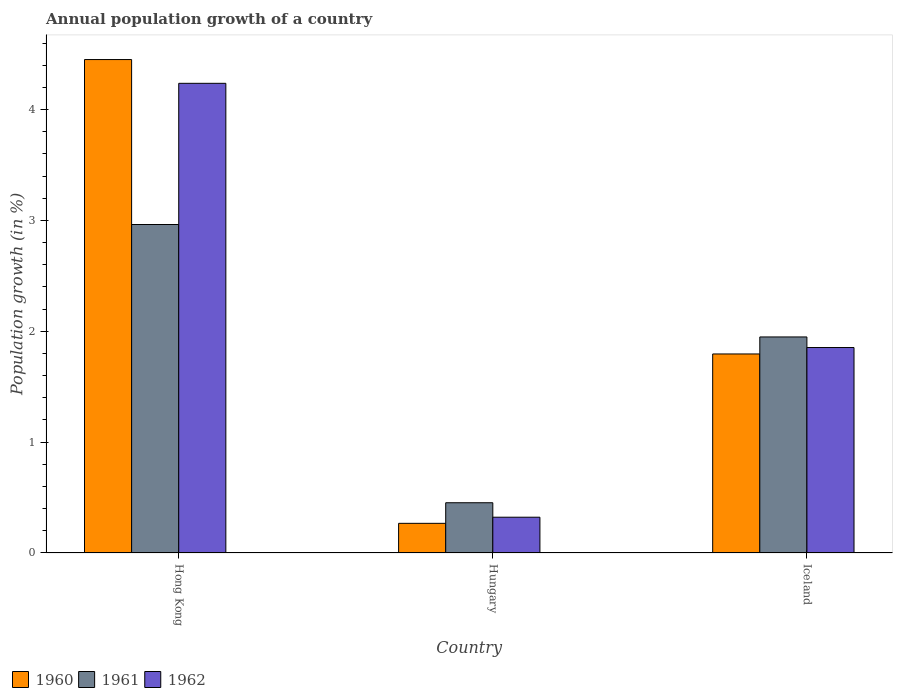How many different coloured bars are there?
Make the answer very short. 3. How many groups of bars are there?
Your response must be concise. 3. Are the number of bars per tick equal to the number of legend labels?
Provide a short and direct response. Yes. Are the number of bars on each tick of the X-axis equal?
Your response must be concise. Yes. How many bars are there on the 2nd tick from the left?
Your answer should be very brief. 3. What is the label of the 3rd group of bars from the left?
Provide a succinct answer. Iceland. In how many cases, is the number of bars for a given country not equal to the number of legend labels?
Give a very brief answer. 0. What is the annual population growth in 1961 in Hong Kong?
Provide a succinct answer. 2.96. Across all countries, what is the maximum annual population growth in 1961?
Provide a succinct answer. 2.96. Across all countries, what is the minimum annual population growth in 1961?
Your answer should be compact. 0.45. In which country was the annual population growth in 1962 maximum?
Provide a succinct answer. Hong Kong. In which country was the annual population growth in 1962 minimum?
Your answer should be compact. Hungary. What is the total annual population growth in 1962 in the graph?
Offer a very short reply. 6.41. What is the difference between the annual population growth in 1960 in Hong Kong and that in Iceland?
Offer a terse response. 2.66. What is the difference between the annual population growth in 1961 in Hungary and the annual population growth in 1962 in Hong Kong?
Keep it short and to the point. -3.78. What is the average annual population growth in 1961 per country?
Provide a succinct answer. 1.79. What is the difference between the annual population growth of/in 1961 and annual population growth of/in 1962 in Hong Kong?
Your answer should be compact. -1.27. In how many countries, is the annual population growth in 1961 greater than 3.8 %?
Your response must be concise. 0. What is the ratio of the annual population growth in 1962 in Hong Kong to that in Iceland?
Offer a very short reply. 2.29. Is the annual population growth in 1960 in Hong Kong less than that in Hungary?
Offer a terse response. No. What is the difference between the highest and the second highest annual population growth in 1960?
Provide a succinct answer. -1.53. What is the difference between the highest and the lowest annual population growth in 1961?
Offer a very short reply. 2.51. Is it the case that in every country, the sum of the annual population growth in 1960 and annual population growth in 1961 is greater than the annual population growth in 1962?
Provide a short and direct response. Yes. Are all the bars in the graph horizontal?
Provide a short and direct response. No. What is the difference between two consecutive major ticks on the Y-axis?
Offer a terse response. 1. Does the graph contain any zero values?
Your response must be concise. No. Where does the legend appear in the graph?
Keep it short and to the point. Bottom left. How many legend labels are there?
Your answer should be very brief. 3. How are the legend labels stacked?
Make the answer very short. Horizontal. What is the title of the graph?
Provide a succinct answer. Annual population growth of a country. Does "1979" appear as one of the legend labels in the graph?
Ensure brevity in your answer.  No. What is the label or title of the Y-axis?
Provide a succinct answer. Population growth (in %). What is the Population growth (in %) in 1960 in Hong Kong?
Your answer should be very brief. 4.45. What is the Population growth (in %) of 1961 in Hong Kong?
Provide a short and direct response. 2.96. What is the Population growth (in %) of 1962 in Hong Kong?
Offer a terse response. 4.24. What is the Population growth (in %) in 1960 in Hungary?
Your answer should be compact. 0.27. What is the Population growth (in %) of 1961 in Hungary?
Your answer should be compact. 0.45. What is the Population growth (in %) of 1962 in Hungary?
Your response must be concise. 0.32. What is the Population growth (in %) in 1960 in Iceland?
Provide a short and direct response. 1.8. What is the Population growth (in %) of 1961 in Iceland?
Offer a very short reply. 1.95. What is the Population growth (in %) of 1962 in Iceland?
Offer a very short reply. 1.85. Across all countries, what is the maximum Population growth (in %) of 1960?
Make the answer very short. 4.45. Across all countries, what is the maximum Population growth (in %) in 1961?
Provide a succinct answer. 2.96. Across all countries, what is the maximum Population growth (in %) of 1962?
Give a very brief answer. 4.24. Across all countries, what is the minimum Population growth (in %) of 1960?
Keep it short and to the point. 0.27. Across all countries, what is the minimum Population growth (in %) in 1961?
Your answer should be compact. 0.45. Across all countries, what is the minimum Population growth (in %) in 1962?
Offer a very short reply. 0.32. What is the total Population growth (in %) of 1960 in the graph?
Your answer should be compact. 6.51. What is the total Population growth (in %) of 1961 in the graph?
Provide a succinct answer. 5.37. What is the total Population growth (in %) of 1962 in the graph?
Ensure brevity in your answer.  6.41. What is the difference between the Population growth (in %) in 1960 in Hong Kong and that in Hungary?
Keep it short and to the point. 4.18. What is the difference between the Population growth (in %) in 1961 in Hong Kong and that in Hungary?
Keep it short and to the point. 2.51. What is the difference between the Population growth (in %) of 1962 in Hong Kong and that in Hungary?
Offer a very short reply. 3.91. What is the difference between the Population growth (in %) in 1960 in Hong Kong and that in Iceland?
Offer a terse response. 2.66. What is the difference between the Population growth (in %) of 1961 in Hong Kong and that in Iceland?
Your answer should be very brief. 1.01. What is the difference between the Population growth (in %) in 1962 in Hong Kong and that in Iceland?
Offer a terse response. 2.38. What is the difference between the Population growth (in %) of 1960 in Hungary and that in Iceland?
Your answer should be very brief. -1.53. What is the difference between the Population growth (in %) in 1961 in Hungary and that in Iceland?
Your answer should be very brief. -1.5. What is the difference between the Population growth (in %) of 1962 in Hungary and that in Iceland?
Your answer should be very brief. -1.53. What is the difference between the Population growth (in %) of 1960 in Hong Kong and the Population growth (in %) of 1961 in Hungary?
Provide a short and direct response. 4. What is the difference between the Population growth (in %) of 1960 in Hong Kong and the Population growth (in %) of 1962 in Hungary?
Your response must be concise. 4.13. What is the difference between the Population growth (in %) in 1961 in Hong Kong and the Population growth (in %) in 1962 in Hungary?
Offer a terse response. 2.64. What is the difference between the Population growth (in %) in 1960 in Hong Kong and the Population growth (in %) in 1961 in Iceland?
Your response must be concise. 2.5. What is the difference between the Population growth (in %) in 1960 in Hong Kong and the Population growth (in %) in 1962 in Iceland?
Your response must be concise. 2.6. What is the difference between the Population growth (in %) in 1961 in Hong Kong and the Population growth (in %) in 1962 in Iceland?
Your response must be concise. 1.11. What is the difference between the Population growth (in %) in 1960 in Hungary and the Population growth (in %) in 1961 in Iceland?
Your answer should be very brief. -1.68. What is the difference between the Population growth (in %) of 1960 in Hungary and the Population growth (in %) of 1962 in Iceland?
Ensure brevity in your answer.  -1.59. What is the difference between the Population growth (in %) in 1961 in Hungary and the Population growth (in %) in 1962 in Iceland?
Your response must be concise. -1.4. What is the average Population growth (in %) of 1960 per country?
Your answer should be very brief. 2.17. What is the average Population growth (in %) in 1961 per country?
Keep it short and to the point. 1.79. What is the average Population growth (in %) of 1962 per country?
Keep it short and to the point. 2.14. What is the difference between the Population growth (in %) of 1960 and Population growth (in %) of 1961 in Hong Kong?
Offer a very short reply. 1.49. What is the difference between the Population growth (in %) in 1960 and Population growth (in %) in 1962 in Hong Kong?
Keep it short and to the point. 0.21. What is the difference between the Population growth (in %) of 1961 and Population growth (in %) of 1962 in Hong Kong?
Offer a terse response. -1.27. What is the difference between the Population growth (in %) of 1960 and Population growth (in %) of 1961 in Hungary?
Offer a very short reply. -0.19. What is the difference between the Population growth (in %) in 1960 and Population growth (in %) in 1962 in Hungary?
Ensure brevity in your answer.  -0.06. What is the difference between the Population growth (in %) of 1961 and Population growth (in %) of 1962 in Hungary?
Offer a very short reply. 0.13. What is the difference between the Population growth (in %) of 1960 and Population growth (in %) of 1961 in Iceland?
Keep it short and to the point. -0.15. What is the difference between the Population growth (in %) of 1960 and Population growth (in %) of 1962 in Iceland?
Your answer should be very brief. -0.06. What is the difference between the Population growth (in %) in 1961 and Population growth (in %) in 1962 in Iceland?
Your answer should be compact. 0.1. What is the ratio of the Population growth (in %) of 1960 in Hong Kong to that in Hungary?
Provide a succinct answer. 16.64. What is the ratio of the Population growth (in %) in 1961 in Hong Kong to that in Hungary?
Your response must be concise. 6.54. What is the ratio of the Population growth (in %) in 1962 in Hong Kong to that in Hungary?
Your answer should be very brief. 13.13. What is the ratio of the Population growth (in %) in 1960 in Hong Kong to that in Iceland?
Offer a terse response. 2.48. What is the ratio of the Population growth (in %) in 1961 in Hong Kong to that in Iceland?
Your answer should be very brief. 1.52. What is the ratio of the Population growth (in %) in 1962 in Hong Kong to that in Iceland?
Your answer should be very brief. 2.29. What is the ratio of the Population growth (in %) of 1960 in Hungary to that in Iceland?
Your answer should be compact. 0.15. What is the ratio of the Population growth (in %) of 1961 in Hungary to that in Iceland?
Keep it short and to the point. 0.23. What is the ratio of the Population growth (in %) in 1962 in Hungary to that in Iceland?
Your response must be concise. 0.17. What is the difference between the highest and the second highest Population growth (in %) of 1960?
Make the answer very short. 2.66. What is the difference between the highest and the second highest Population growth (in %) of 1961?
Give a very brief answer. 1.01. What is the difference between the highest and the second highest Population growth (in %) of 1962?
Provide a succinct answer. 2.38. What is the difference between the highest and the lowest Population growth (in %) of 1960?
Offer a terse response. 4.18. What is the difference between the highest and the lowest Population growth (in %) in 1961?
Offer a very short reply. 2.51. What is the difference between the highest and the lowest Population growth (in %) in 1962?
Offer a terse response. 3.91. 